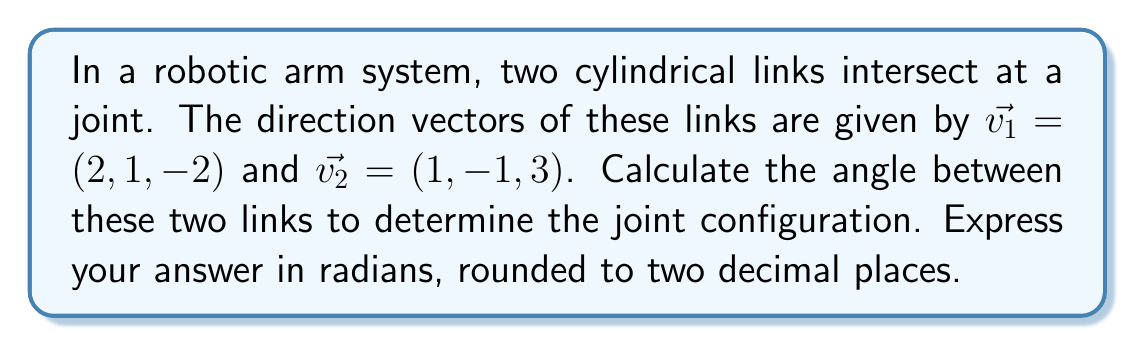Can you answer this question? To find the angle between two intersecting lines in 3D space, we can use the dot product formula:

$$\cos \theta = \frac{\vec{v_1} \cdot \vec{v_2}}{|\vec{v_1}||\vec{v_2}|}$$

Where $\theta$ is the angle between the vectors, $\vec{v_1} \cdot \vec{v_2}$ is the dot product, and $|\vec{v_1}|$ and $|\vec{v_2}|$ are the magnitudes of the vectors.

Step 1: Calculate the dot product $\vec{v_1} \cdot \vec{v_2}$
$$\vec{v_1} \cdot \vec{v_2} = (2)(1) + (1)(-1) + (-2)(3) = 2 - 1 - 6 = -5$$

Step 2: Calculate the magnitudes of the vectors
$$|\vec{v_1}| = \sqrt{2^2 + 1^2 + (-2)^2} = \sqrt{4 + 1 + 4} = \sqrt{9} = 3$$
$$|\vec{v_2}| = \sqrt{1^2 + (-1)^2 + 3^2} = \sqrt{1 + 1 + 9} = \sqrt{11}$$

Step 3: Apply the dot product formula
$$\cos \theta = \frac{-5}{3\sqrt{11}}$$

Step 4: Take the inverse cosine (arccos) of both sides
$$\theta = \arccos\left(\frac{-5}{3\sqrt{11}}\right) \approx 2.21 \text{ radians}$$

Rounding to two decimal places gives us 2.21 radians.
Answer: 2.21 radians 